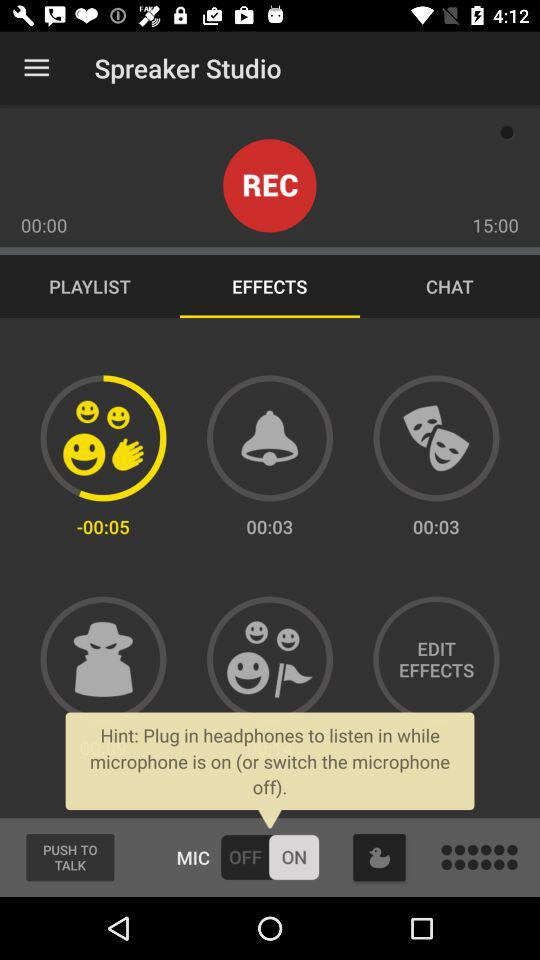What is the setting for the mic? The setting for the mic is "on". 